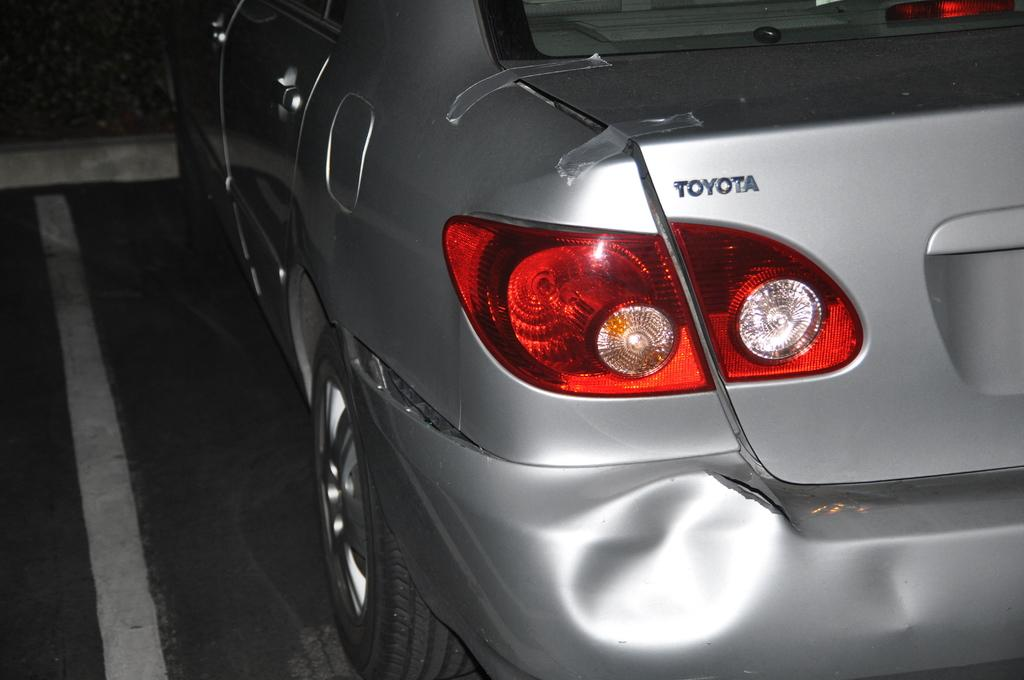What is the main subject of the picture? The main subject of the picture is a car. Where is the car located in the image? The car is parked on a parking lot. Can you describe any text or words on the car? Yes, there is a word written on the car. What type of damage can be seen on the car? There is a dent visible at the bottom of the picture. What month is it in the picture? The month cannot be determined from the image, as it does not contain any information about the time of year. Can you see a hen in the picture? No, there is no hen present in the image. 